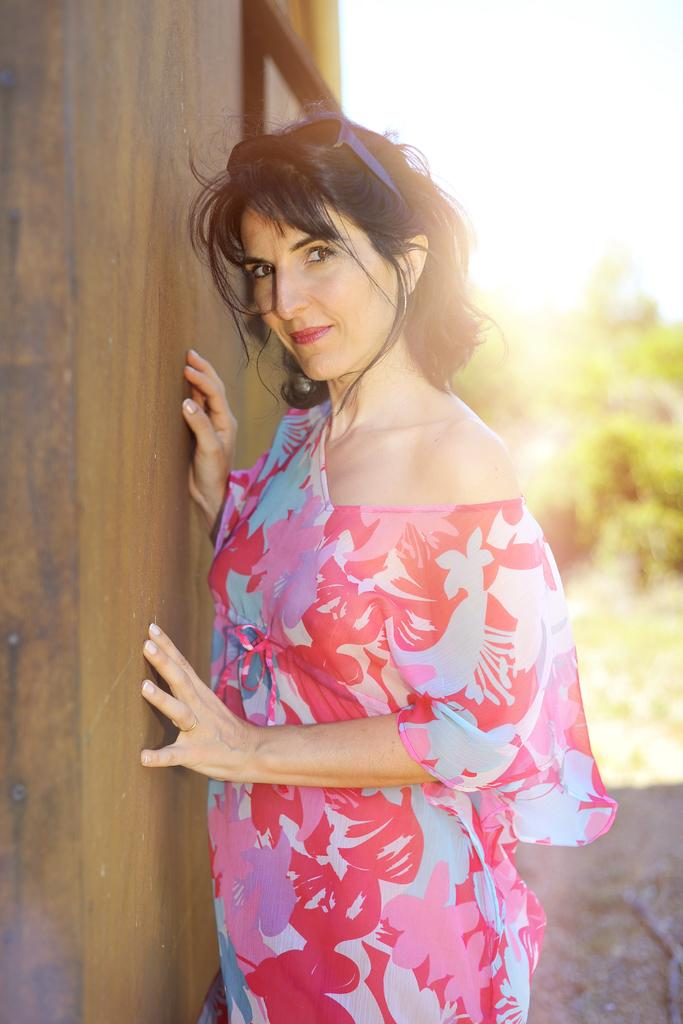Who is present in the image? There is a woman in the image. What is the woman wearing? The woman is wearing a red dress. Where is the woman standing in relation to the wooden wall? The woman is standing beside a wooden wall. What type of vegetation can be seen in the image? There are trees visible in the image. What is the location of the trees? The trees are on land. What is visible above the trees? The sky is visible above the trees. What type of thunder can be heard in the image? There is no thunder present in the image, as it is a visual representation and does not include sound. 